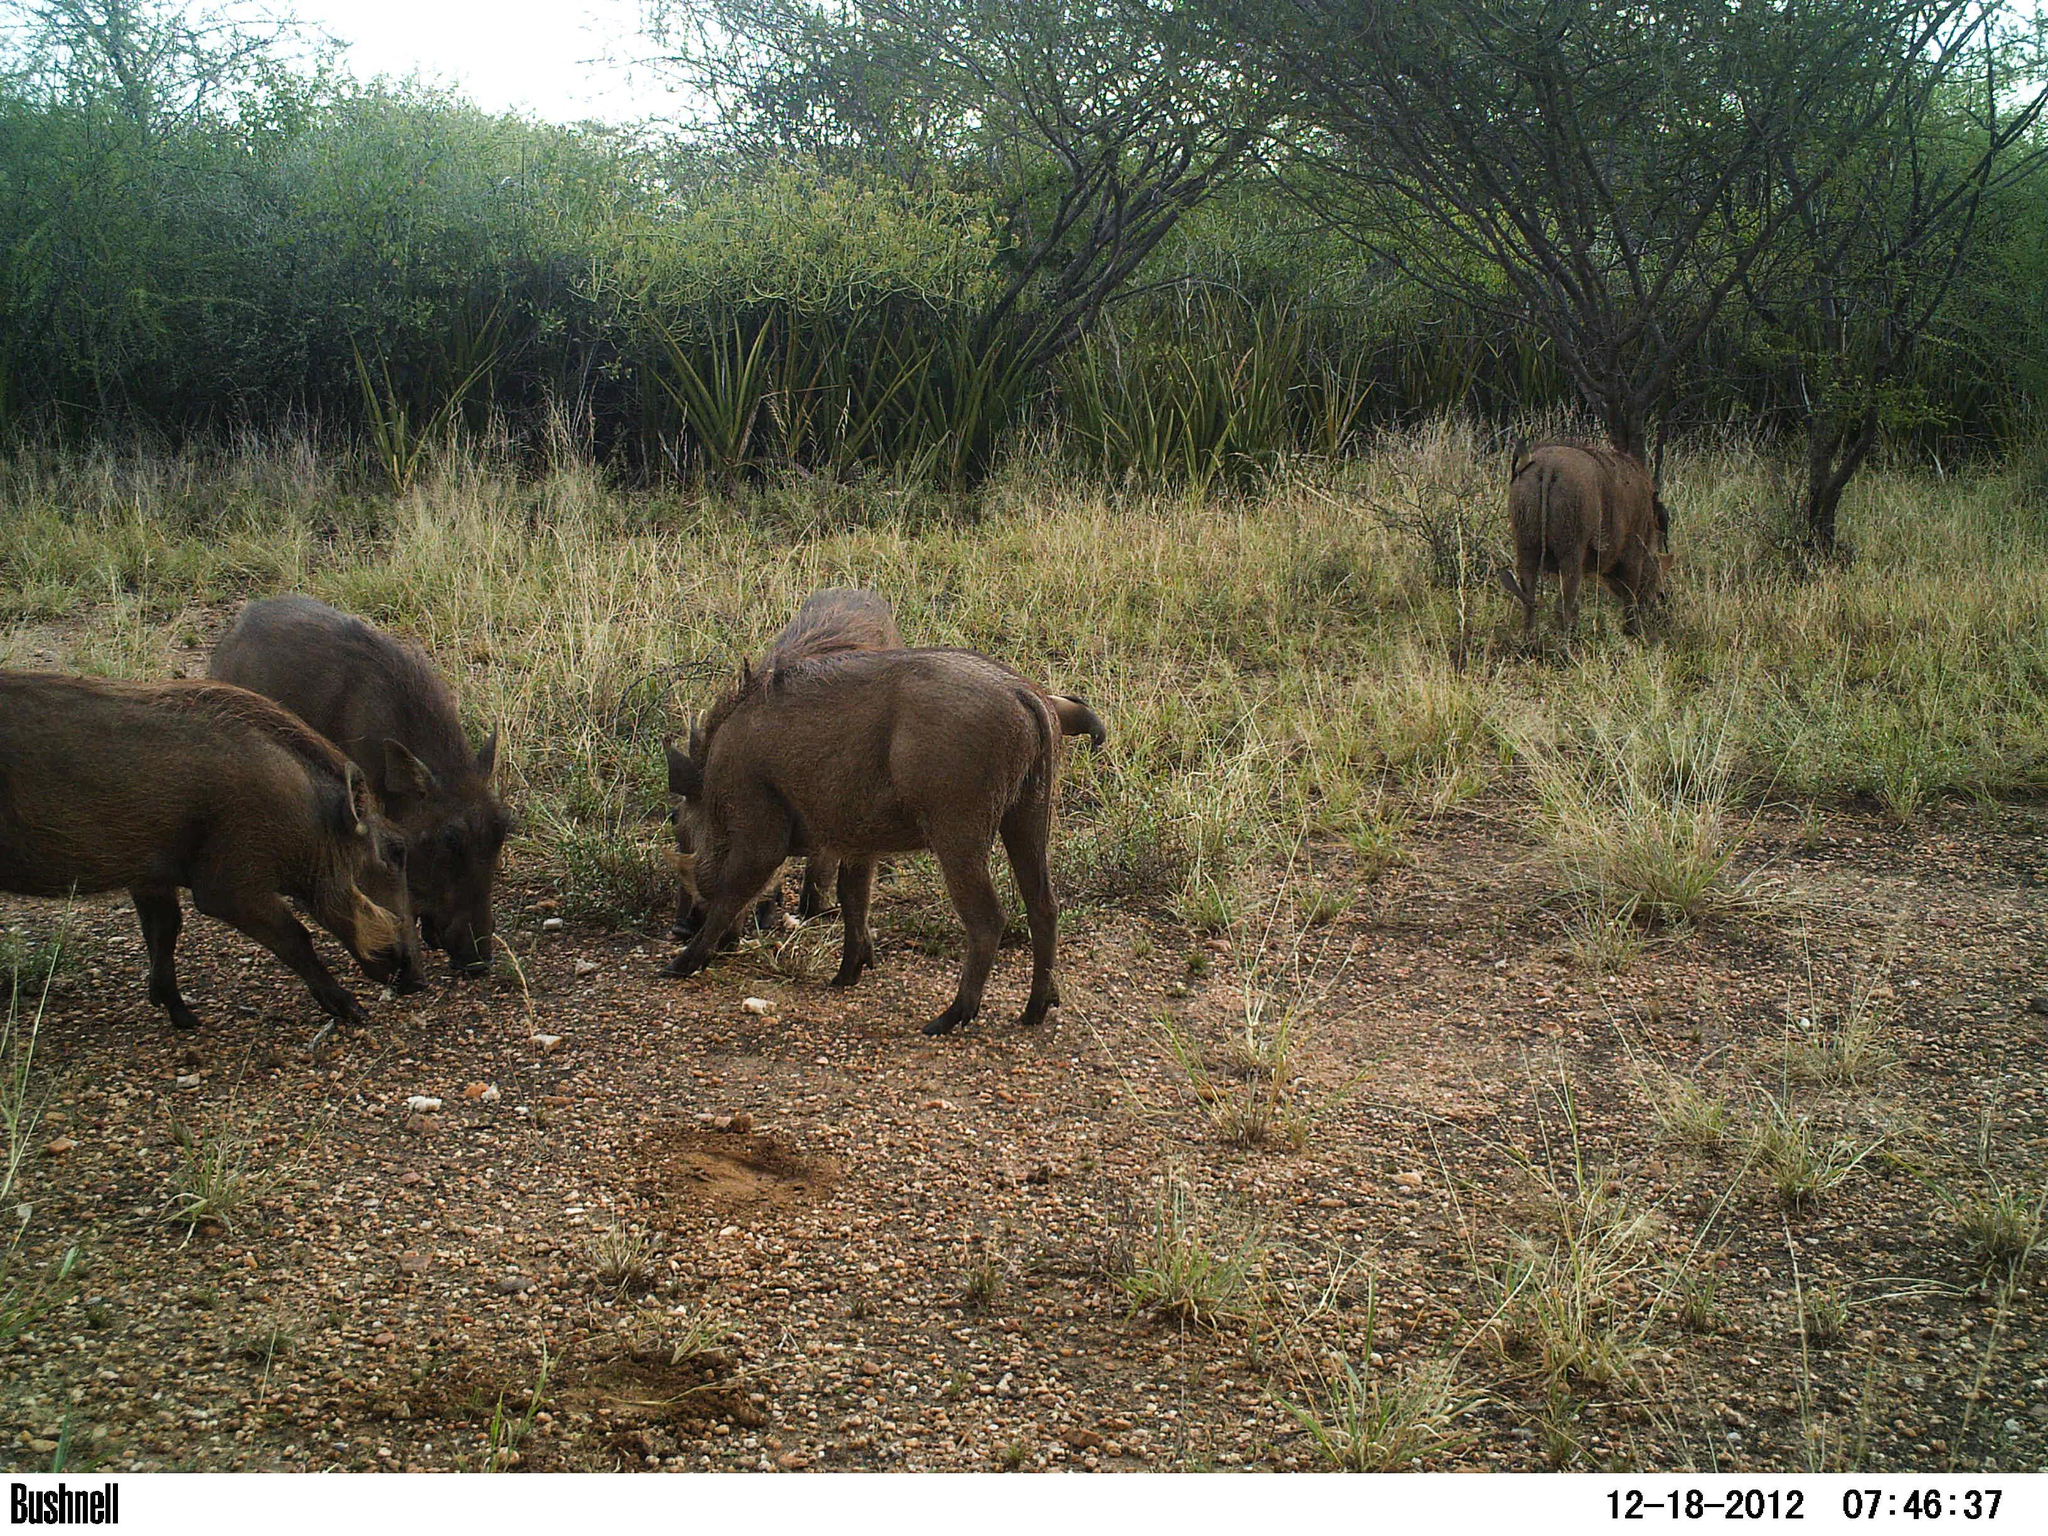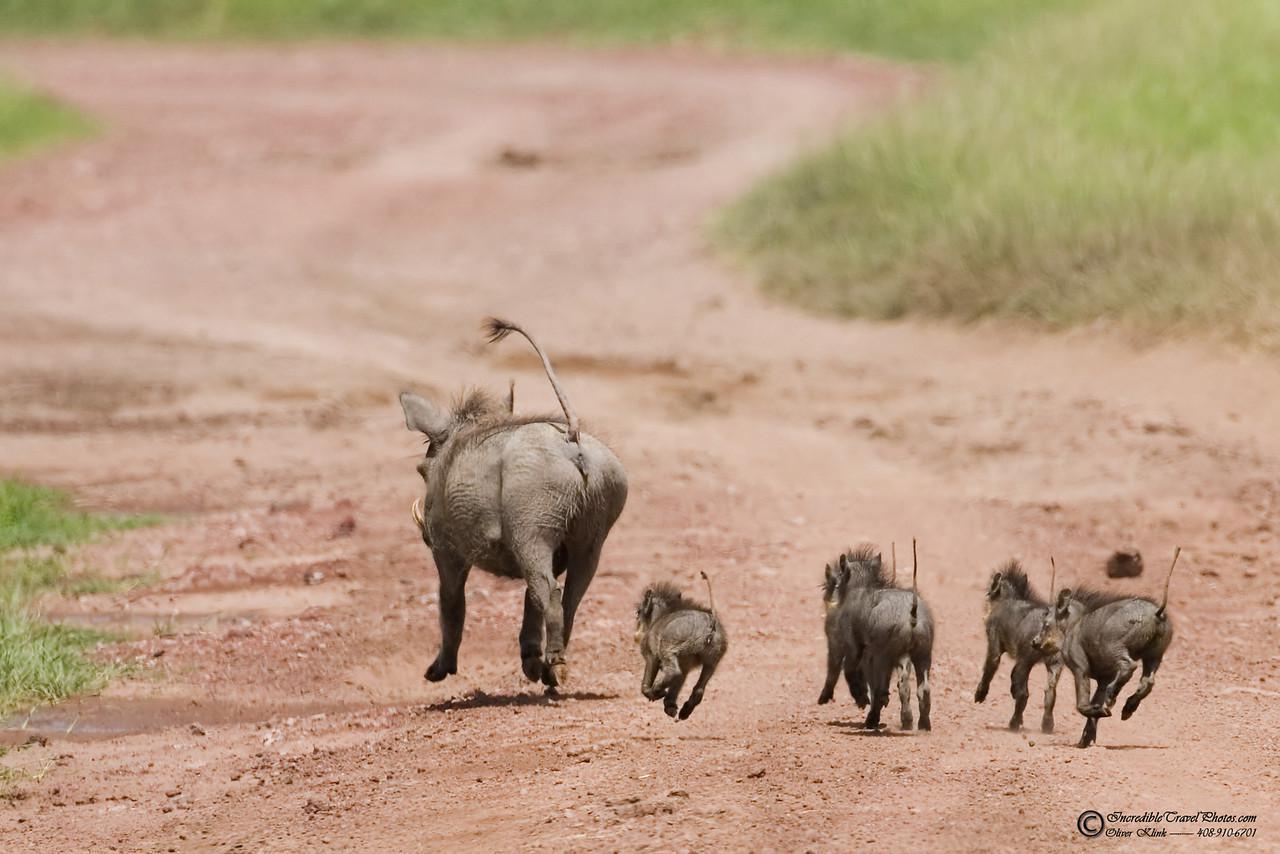The first image is the image on the left, the second image is the image on the right. Assess this claim about the two images: "An image shows at least four young warthogs and an adult moving along a wide dirt path flanked by grass.". Correct or not? Answer yes or no. Yes. The first image is the image on the left, the second image is the image on the right. Given the left and right images, does the statement "The right image contains exactly five warthogs." hold true? Answer yes or no. Yes. 